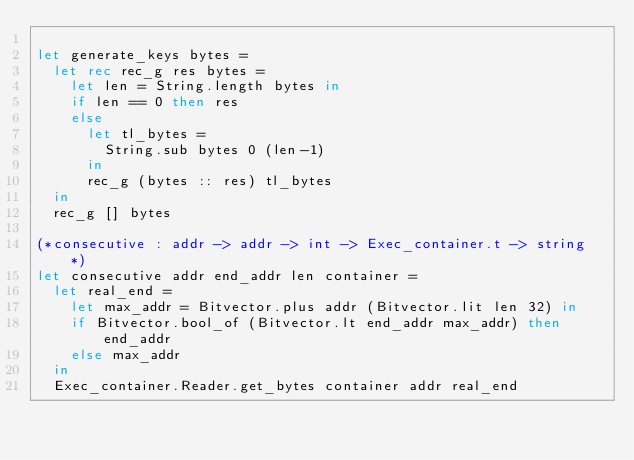<code> <loc_0><loc_0><loc_500><loc_500><_OCaml_>
let generate_keys bytes =
  let rec rec_g res bytes =
    let len = String.length bytes in
    if len == 0 then res
    else
      let tl_bytes = 
        String.sub bytes 0 (len-1)
      in
      rec_g (bytes :: res) tl_bytes
  in
  rec_g [] bytes

(*consecutive : addr -> addr -> int -> Exec_container.t -> string *)
let consecutive addr end_addr len container =
  let real_end =
    let max_addr = Bitvector.plus addr (Bitvector.lit len 32) in
    if Bitvector.bool_of (Bitvector.lt end_addr max_addr) then end_addr
    else max_addr
  in
  Exec_container.Reader.get_bytes container addr real_end
</code> 